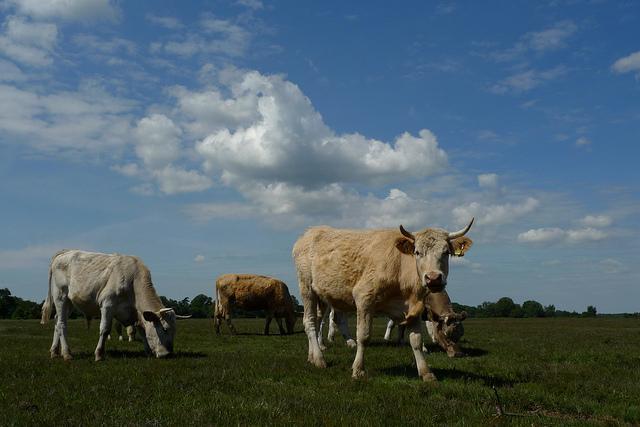How many of the cattle are not grazing?
Give a very brief answer. 1. How many cows are there?
Give a very brief answer. 4. How many cows are in the photo?
Give a very brief answer. 3. How many trucks do you see?
Give a very brief answer. 0. 